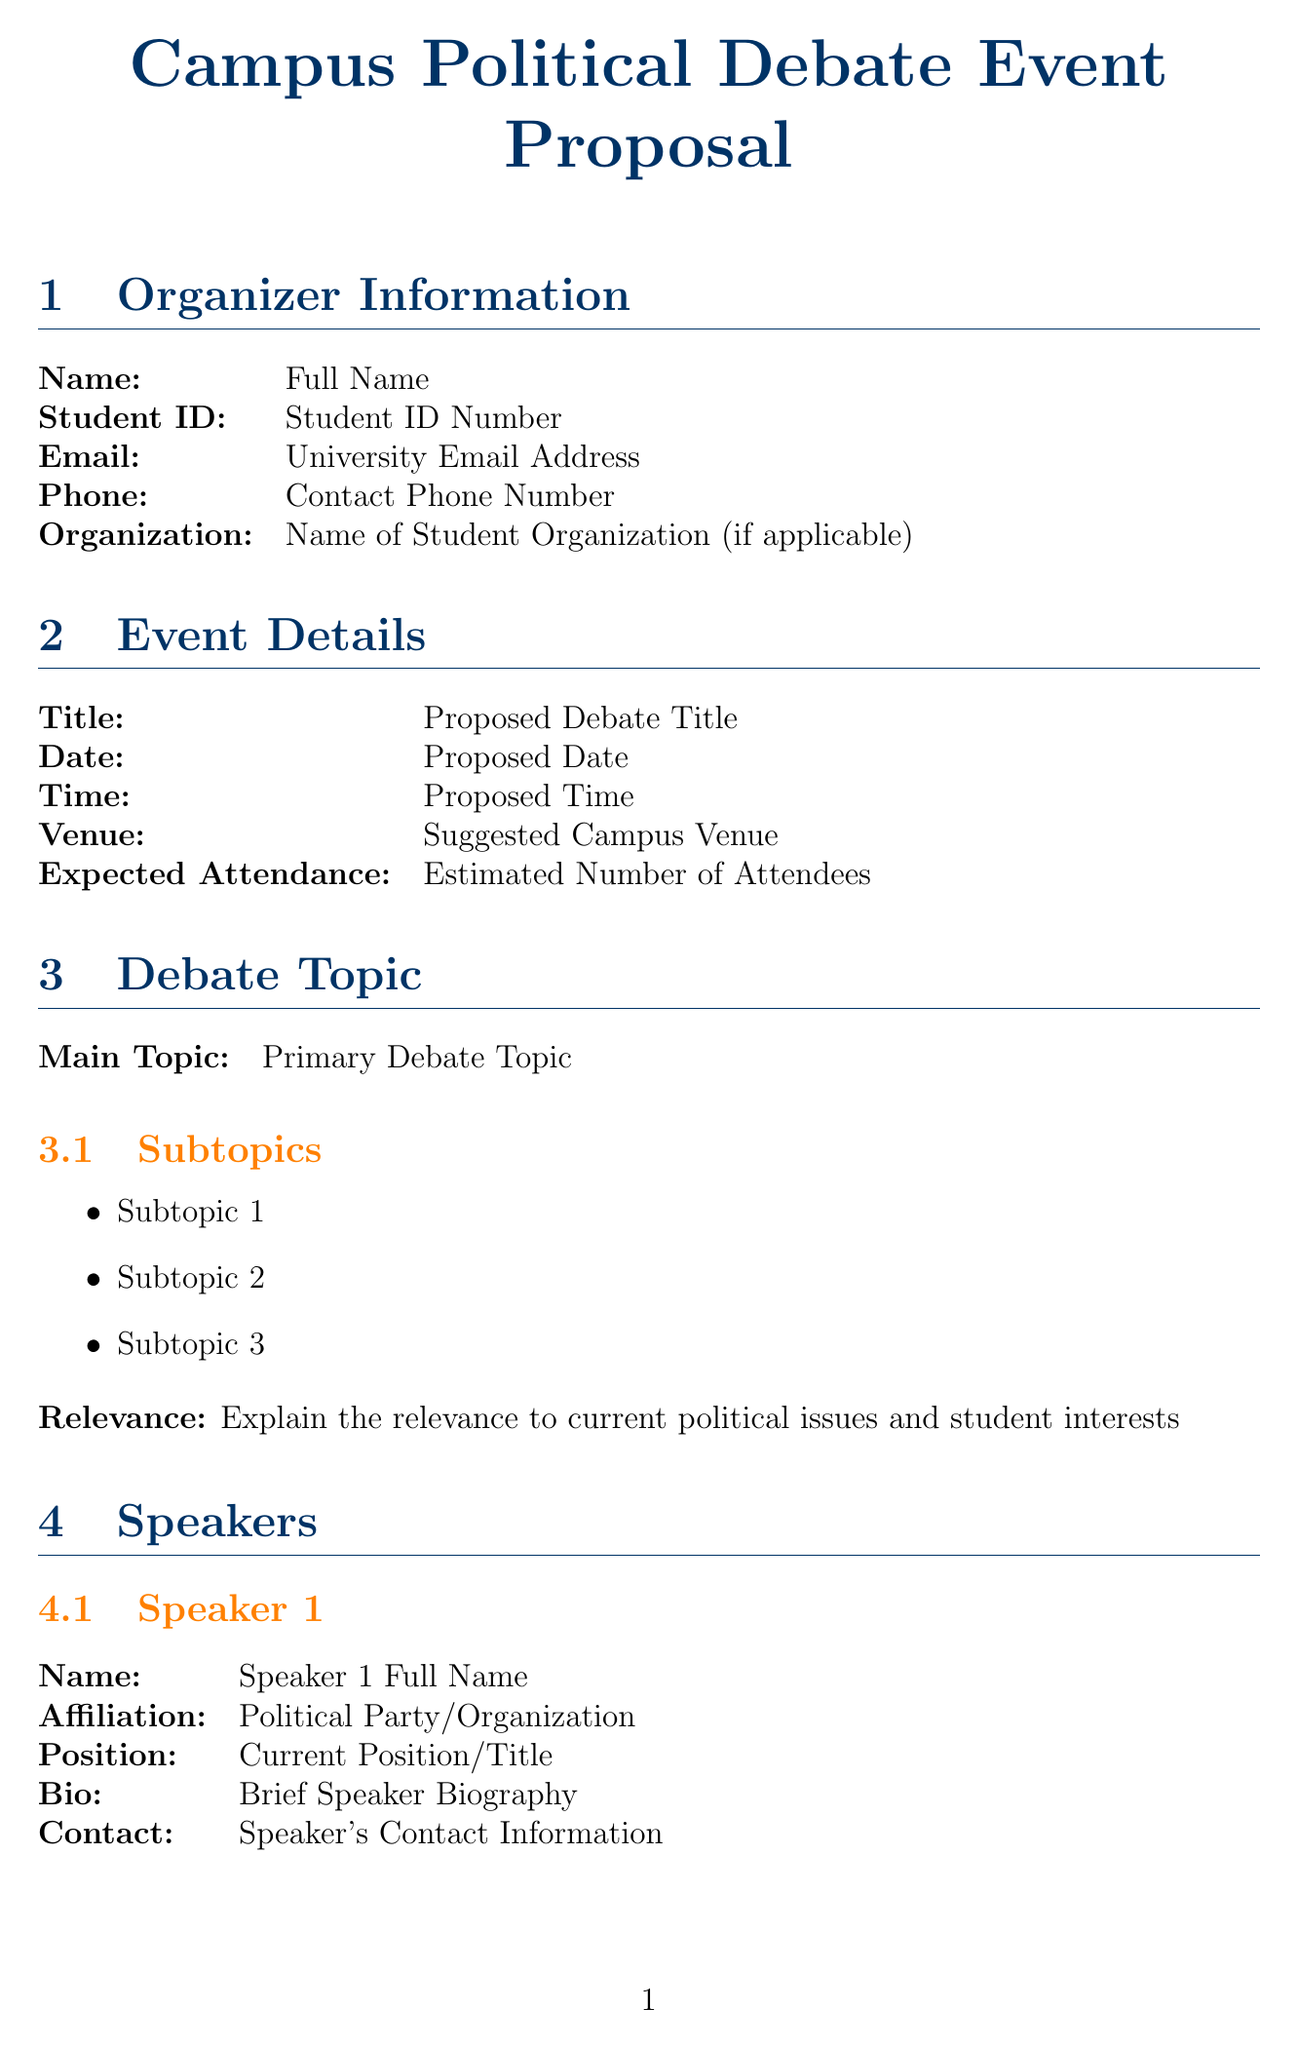What is the proposed date for the debate? The proposed date is specified under the event details section of the document.
Answer: Proposed Date Who is the moderator of the debate? The name of the moderator is indicated in the moderator section of the document.
Answer: Moderator Full Name How many volunteers are needed? The number of volunteers required is noted under the logistics section in the document.
Answer: Number of Volunteers Required What are the estimated costs for refreshments? The estimated costs for provided refreshments can be found in the budget section of the document.
Answer: Cost for Any Provided Refreshments What is the main topic of the debate? The primary debate topic is listed under the debate topic section of the document.
Answer: Primary Debate Topic Explain the reason for the debate's relevance. This necessitates a synthesis of information about the debate topic and current political issues mentioned in the document.
Answer: Explain the relevance to current political issues and student interests What type of promotional materials will be used? The types of promotional materials are detailed in the promotion plan section of the document.
Answer: Cost for Flyers, Banners, etc Which departmental approval is needed? The necessary approvals are outlined in the approvals needed section of the document.
Answer: Faculty Advisor Signature What is the total estimated budget? The total estimated budget for the event is indicated in the budget section of the document.
Answer: Total Estimated Budget 